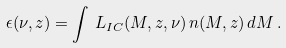Convert formula to latex. <formula><loc_0><loc_0><loc_500><loc_500>\epsilon ( \nu , z ) = \int \, L _ { I C } ( M , z , \nu ) \, n ( M , z ) \, d M \, .</formula> 